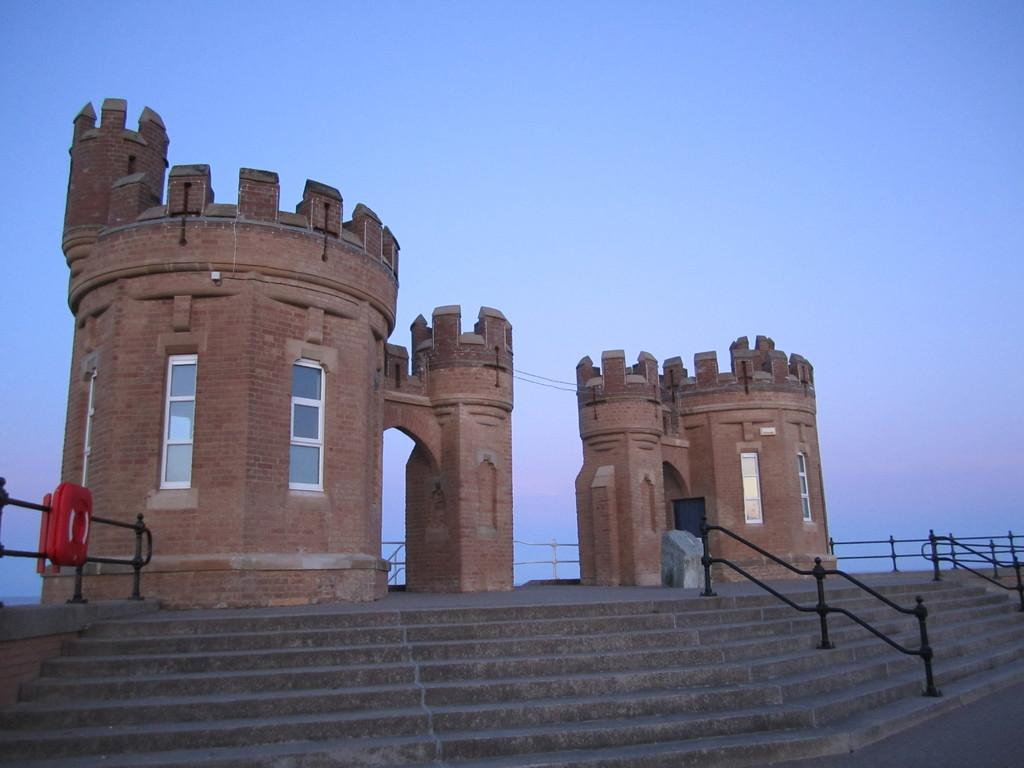How many buildings with windows can be seen in the image? There are two buildings with windows in the image. What is located in the foreground of the image? There is a staircase and metal railings in the foreground of the image. What can be seen in the background of the image? The sky is visible in the background of the image. Can you see any children playing with a kite in the park in the image? There is no park or children playing with a kite in the image; it features two buildings with windows, a staircase, metal railings, and the sky. 